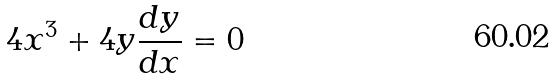Convert formula to latex. <formula><loc_0><loc_0><loc_500><loc_500>4 x ^ { 3 } + 4 y \frac { d y } { d x } = 0</formula> 